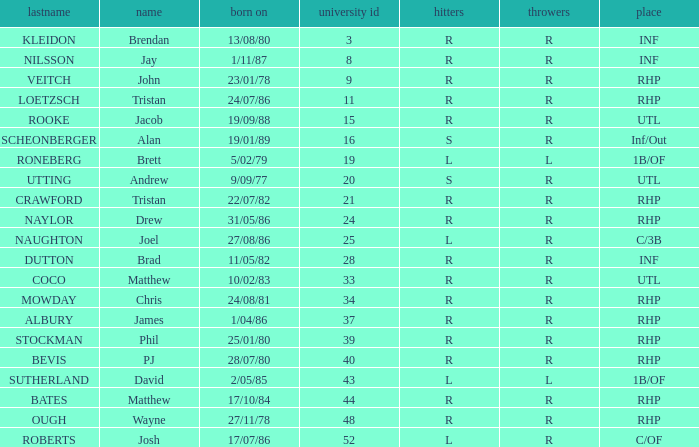Which Surname has Throws of l, and a DOB of 5/02/79? RONEBERG. 